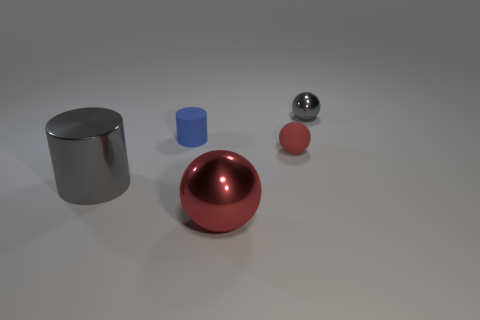Is the number of large gray shiny things that are behind the tiny gray thing the same as the number of small blue cylinders?
Give a very brief answer. No. There is a tiny blue thing; are there any tiny metal things on the left side of it?
Ensure brevity in your answer.  No. There is a metal sphere that is to the right of the sphere that is to the left of the red thing behind the big red sphere; what size is it?
Give a very brief answer. Small. Does the red thing to the left of the tiny rubber ball have the same shape as the gray thing that is to the right of the large shiny cylinder?
Provide a short and direct response. Yes. What size is the gray thing that is the same shape as the blue object?
Offer a terse response. Large. What number of cylinders have the same material as the big sphere?
Ensure brevity in your answer.  1. What material is the blue cylinder?
Offer a very short reply. Rubber. What shape is the metal object that is on the right side of the red object in front of the red matte sphere?
Ensure brevity in your answer.  Sphere. What is the shape of the shiny object to the right of the red metallic sphere?
Your answer should be compact. Sphere. What number of other metal cylinders have the same color as the metallic cylinder?
Give a very brief answer. 0. 